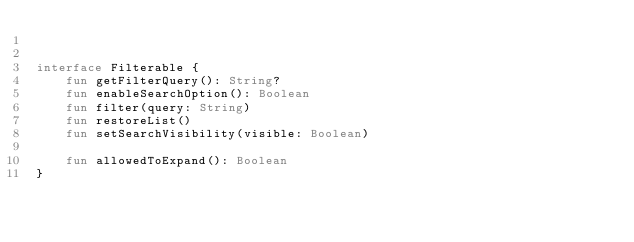<code> <loc_0><loc_0><loc_500><loc_500><_Kotlin_>

interface Filterable {
    fun getFilterQuery(): String?
    fun enableSearchOption(): Boolean
    fun filter(query: String)
    fun restoreList()
    fun setSearchVisibility(visible: Boolean)

    fun allowedToExpand(): Boolean
}
</code> 